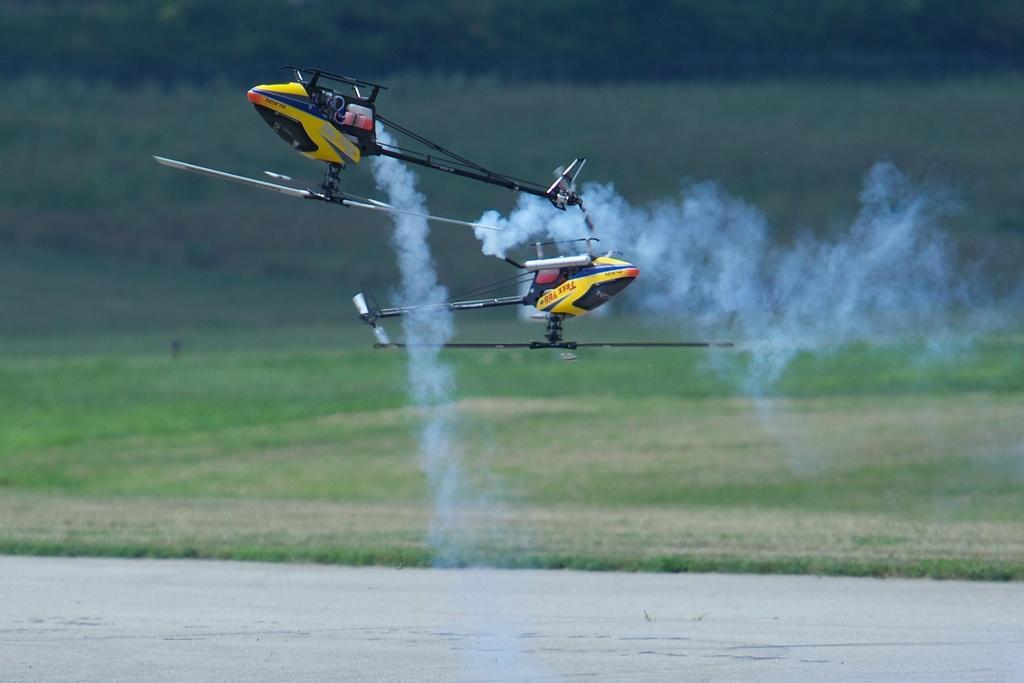Describe this image in one or two sentences. Smoke is coming out from these helicopters. Land is covered with grass. 